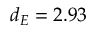Convert formula to latex. <formula><loc_0><loc_0><loc_500><loc_500>d _ { E } = 2 . 9 3</formula> 